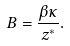<formula> <loc_0><loc_0><loc_500><loc_500>B = \frac { \beta \kappa } { z ^ { * } } .</formula> 